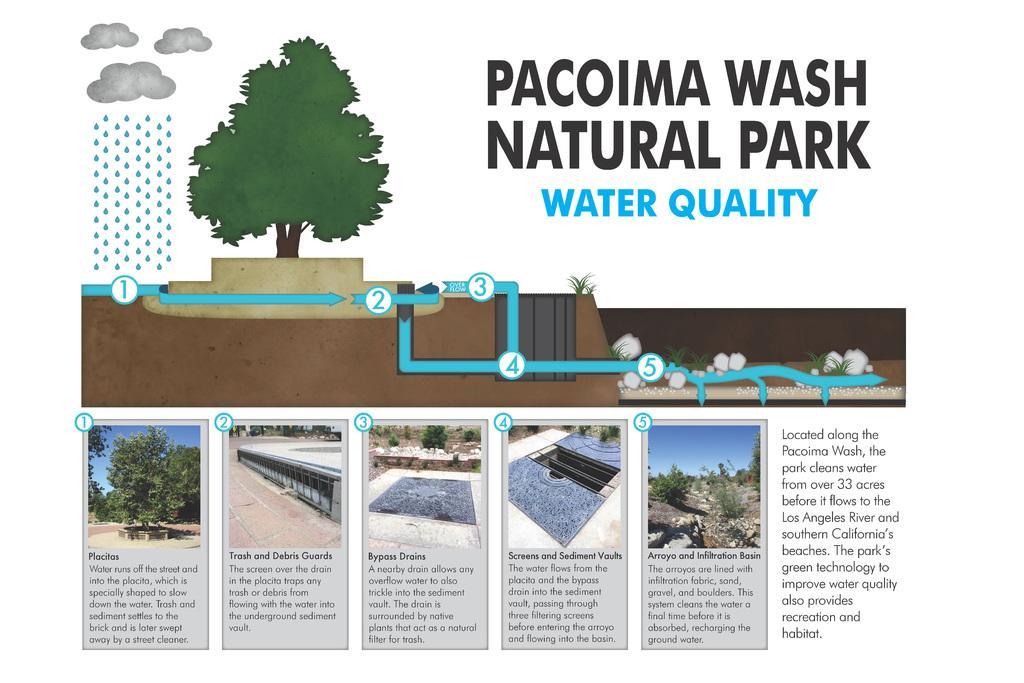Describe this image in one or two sentences. In this image I can see the articles in which I can see the pictures of trees, rocks, plants, trees and I can also see the clouds, rain. I can see the name written on the article. 